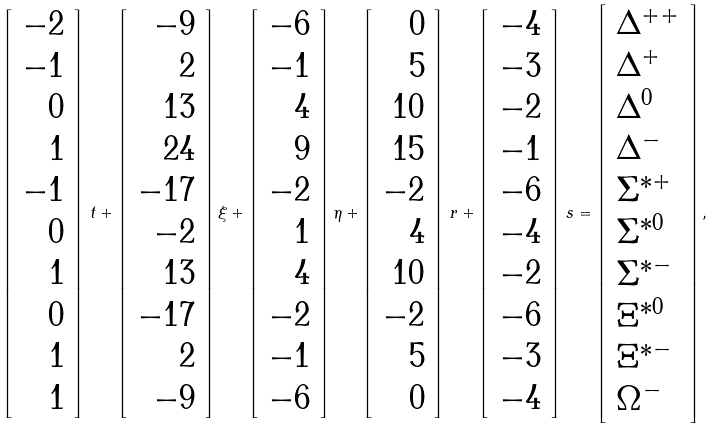Convert formula to latex. <formula><loc_0><loc_0><loc_500><loc_500>\left [ \begin{array} { r } { - 2 } \\ { - 1 } \\ { 0 } \\ { 1 } \\ { - 1 } \\ { 0 } \\ { 1 } \\ { 0 } \\ { 1 } \\ { 1 } \end{array} \right ] \, t + \left [ \begin{array} { r } { - 9 } \\ { 2 } \\ { 1 3 } \\ { 2 4 } \\ { - 1 7 } \\ { - 2 } \\ { 1 3 } \\ { - 1 7 } \\ { 2 } \\ { - 9 } \end{array} \right ] \xi + \left [ \begin{array} { r } { - 6 } \\ { - 1 } \\ { 4 } \\ { 9 } \\ { - 2 } \\ { 1 } \\ { 4 } \\ { - 2 } \\ { - 1 } \\ { - 6 } \end{array} \right ] \eta + \left [ \begin{array} { r } { 0 } \\ { 5 } \\ { 1 0 } \\ { 1 5 } \\ { - 2 } \\ { 4 } \\ { 1 0 } \\ { - 2 } \\ { 5 } \\ { 0 } \end{array} \right ] \, r + \left [ \begin{array} { r } { - 4 } \\ { - 3 } \\ { - 2 } \\ { - 1 } \\ { - 6 } \\ { - 4 } \\ { - 2 } \\ { - 6 } \\ { - 3 } \\ { - 4 } \end{array} \right ] \, s = \left [ \begin{array} { l } { { \Delta ^ { + + } } } \\ { { \Delta ^ { + } } } \\ { { \Delta ^ { 0 } } } \\ { { \Delta ^ { - } } } \\ { { \Sigma ^ { * + } } } \\ { { \Sigma ^ { * 0 } } } \\ { { \Sigma ^ { * - } } } \\ { { \Xi ^ { * 0 } } } \\ { { \Xi ^ { * - } } } \\ { { \Omega ^ { - } } } \end{array} \right ] ,</formula> 